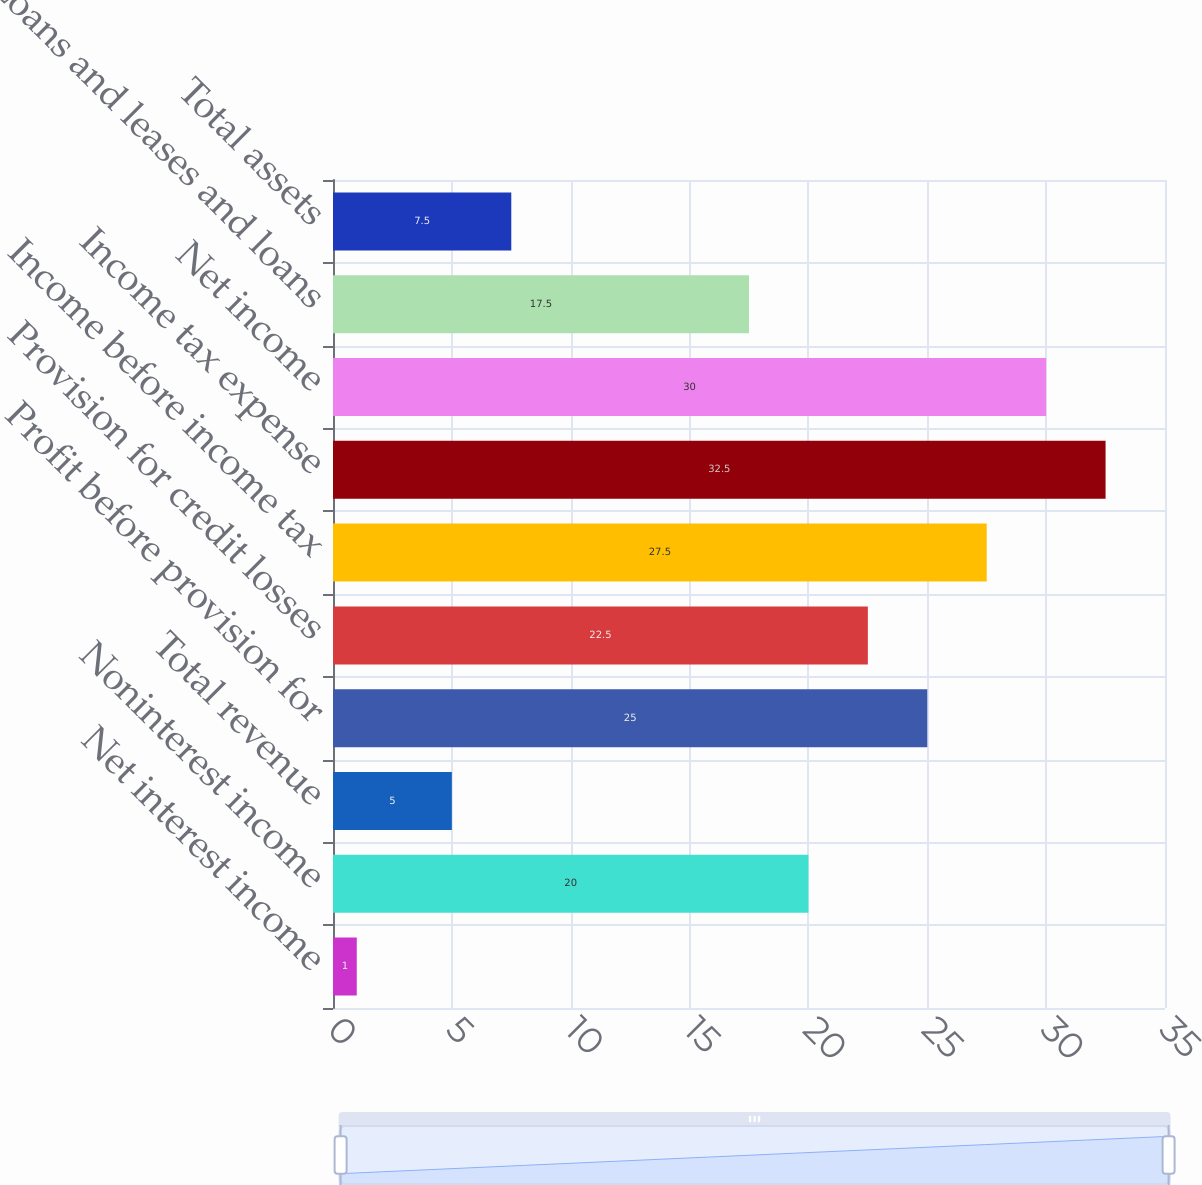Convert chart. <chart><loc_0><loc_0><loc_500><loc_500><bar_chart><fcel>Net interest income<fcel>Noninterest income<fcel>Total revenue<fcel>Profit before provision for<fcel>Provision for credit losses<fcel>Income before income tax<fcel>Income tax expense<fcel>Net income<fcel>Loans and leases and loans<fcel>Total assets<nl><fcel>1<fcel>20<fcel>5<fcel>25<fcel>22.5<fcel>27.5<fcel>32.5<fcel>30<fcel>17.5<fcel>7.5<nl></chart> 